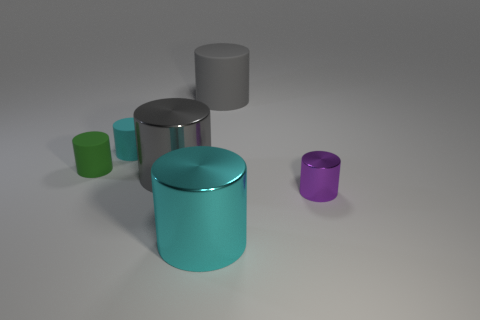Subtract all green cylinders. How many cylinders are left? 5 Subtract all purple cylinders. How many cylinders are left? 5 Subtract all brown cylinders. Subtract all brown spheres. How many cylinders are left? 6 Add 1 small red metallic objects. How many objects exist? 7 Subtract all small gray balls. Subtract all tiny purple cylinders. How many objects are left? 5 Add 1 metallic cylinders. How many metallic cylinders are left? 4 Add 1 large gray spheres. How many large gray spheres exist? 1 Subtract 0 cyan spheres. How many objects are left? 6 